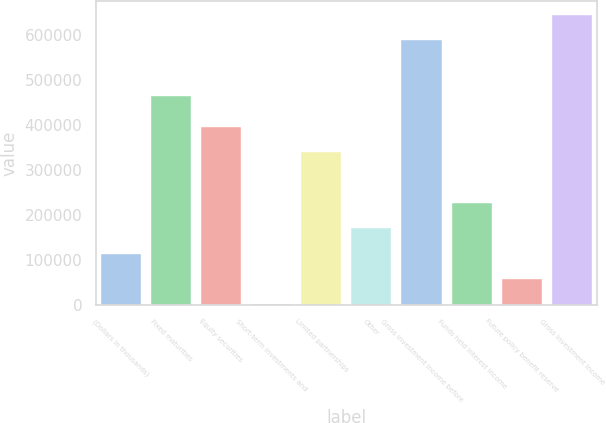Convert chart to OTSL. <chart><loc_0><loc_0><loc_500><loc_500><bar_chart><fcel>(Dollars in thousands)<fcel>Fixed maturities<fcel>Equity securities<fcel>Short-term investments and<fcel>Limited partnerships<fcel>Other<fcel>Gross investment income before<fcel>Funds held interest income<fcel>Future policy benefit reserve<fcel>Gross investment income<nl><fcel>114079<fcel>462757<fcel>395190<fcel>1635<fcel>338968<fcel>170302<fcel>586792<fcel>226524<fcel>57857.2<fcel>643014<nl></chart> 